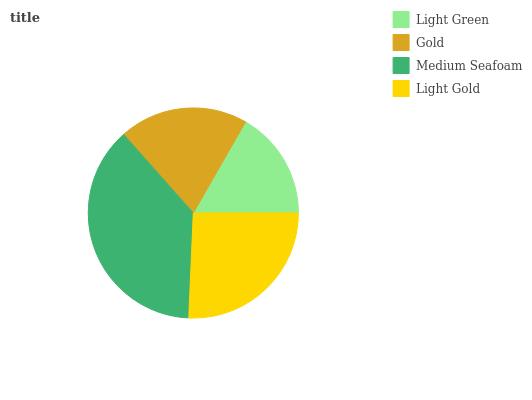Is Light Green the minimum?
Answer yes or no. Yes. Is Medium Seafoam the maximum?
Answer yes or no. Yes. Is Gold the minimum?
Answer yes or no. No. Is Gold the maximum?
Answer yes or no. No. Is Gold greater than Light Green?
Answer yes or no. Yes. Is Light Green less than Gold?
Answer yes or no. Yes. Is Light Green greater than Gold?
Answer yes or no. No. Is Gold less than Light Green?
Answer yes or no. No. Is Light Gold the high median?
Answer yes or no. Yes. Is Gold the low median?
Answer yes or no. Yes. Is Medium Seafoam the high median?
Answer yes or no. No. Is Medium Seafoam the low median?
Answer yes or no. No. 